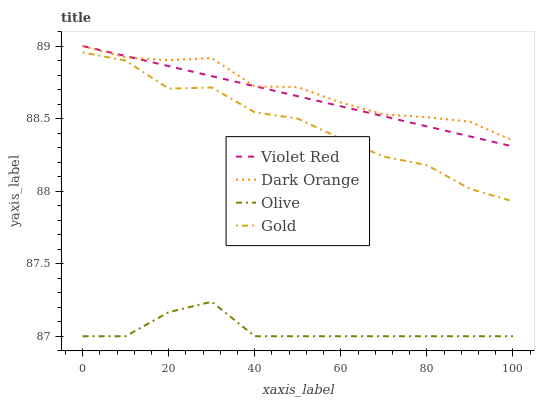Does Olive have the minimum area under the curve?
Answer yes or no. Yes. Does Dark Orange have the maximum area under the curve?
Answer yes or no. Yes. Does Violet Red have the minimum area under the curve?
Answer yes or no. No. Does Violet Red have the maximum area under the curve?
Answer yes or no. No. Is Violet Red the smoothest?
Answer yes or no. Yes. Is Gold the roughest?
Answer yes or no. Yes. Is Dark Orange the smoothest?
Answer yes or no. No. Is Dark Orange the roughest?
Answer yes or no. No. Does Olive have the lowest value?
Answer yes or no. Yes. Does Violet Red have the lowest value?
Answer yes or no. No. Does Violet Red have the highest value?
Answer yes or no. Yes. Does Gold have the highest value?
Answer yes or no. No. Is Gold less than Violet Red?
Answer yes or no. Yes. Is Violet Red greater than Olive?
Answer yes or no. Yes. Does Dark Orange intersect Violet Red?
Answer yes or no. Yes. Is Dark Orange less than Violet Red?
Answer yes or no. No. Is Dark Orange greater than Violet Red?
Answer yes or no. No. Does Gold intersect Violet Red?
Answer yes or no. No. 